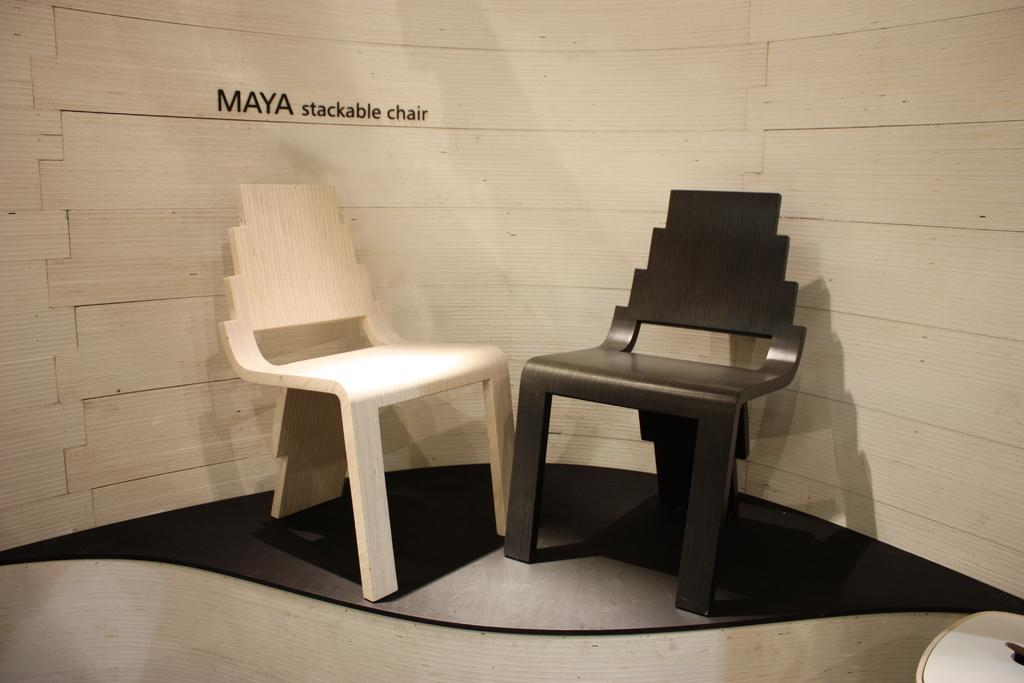What type of furniture is present in the image? There are two wooden chairs in the image. What color are the chairs? The chairs are in black and white color. What can be seen in the background of the image? There is a wooden wall in the background of the image. What is visible at the bottom of the image? There is a floor visible at the bottom of the image. How many bikes are parked near the wooden chairs in the image? There are no bikes present in the image; it only features two wooden chairs. What type of spot is visible on the wooden wall in the image? There is no spot visible on the wooden wall in the image; it is a plain wooden wall. 